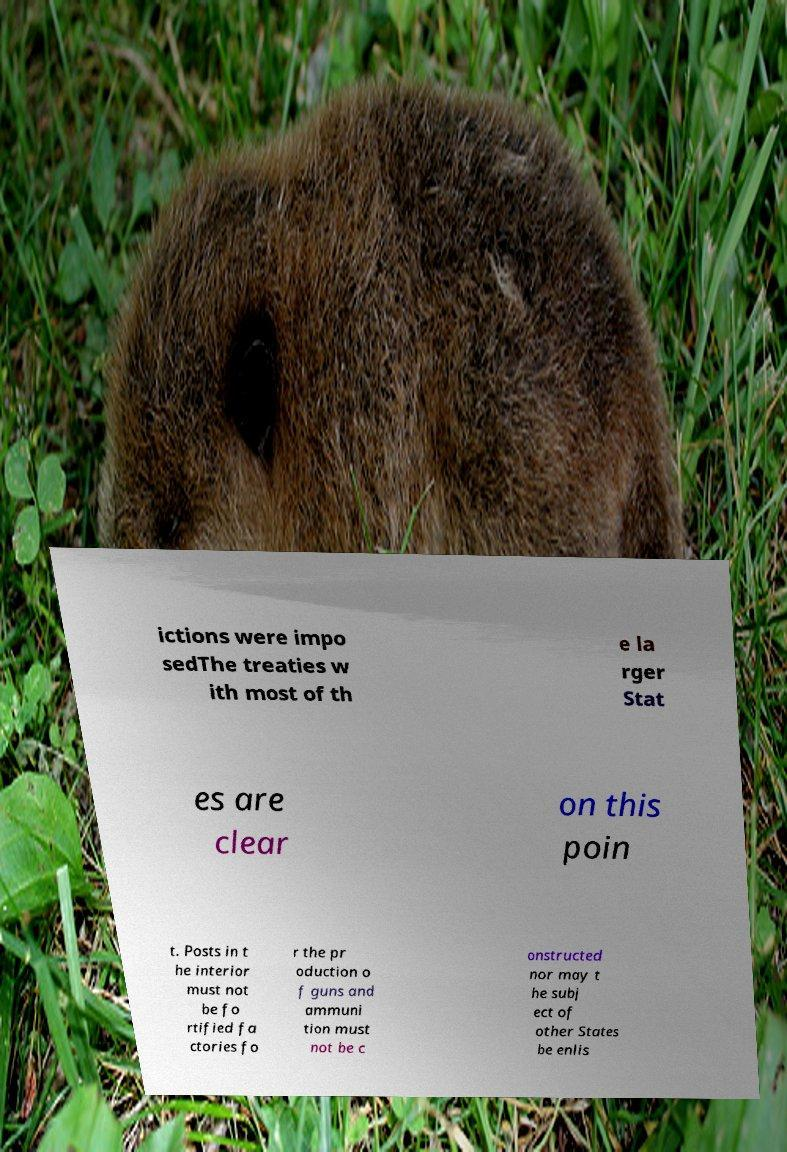There's text embedded in this image that I need extracted. Can you transcribe it verbatim? ictions were impo sedThe treaties w ith most of th e la rger Stat es are clear on this poin t. Posts in t he interior must not be fo rtified fa ctories fo r the pr oduction o f guns and ammuni tion must not be c onstructed nor may t he subj ect of other States be enlis 